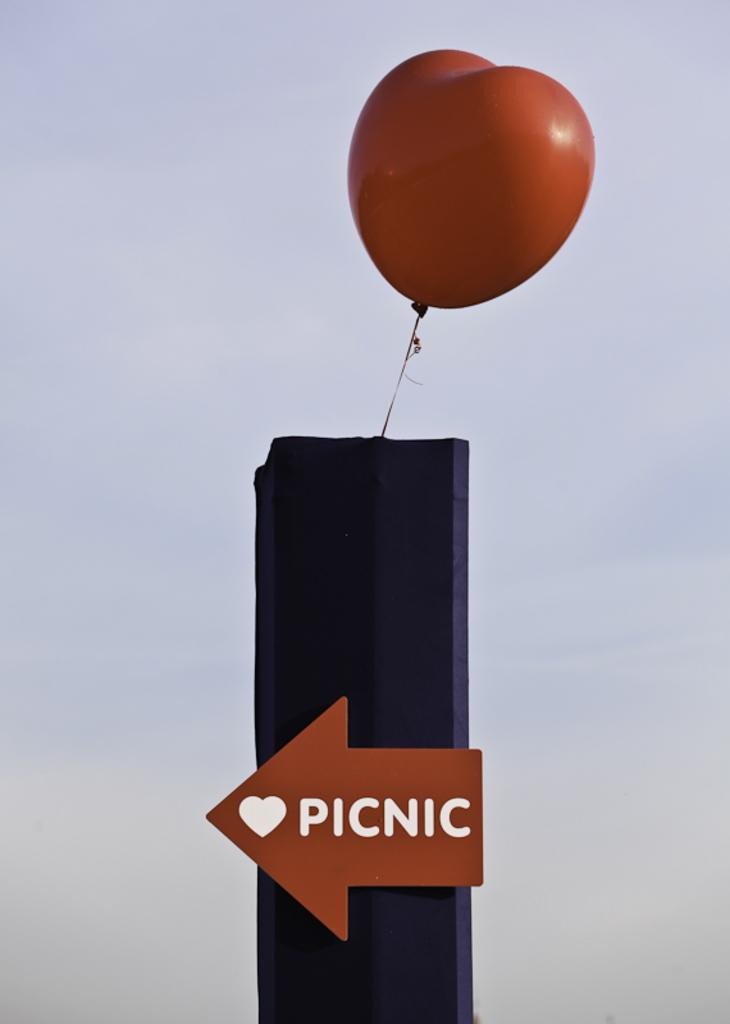What is the main object in the image? There is a balloon in the image. Where is the balloon located in the image? The balloon is at the top of the image. What can be seen in the background of the image? There is sky visible in the image. What word is written at the bottom of the image? The word "picnic" is written at the bottom of the image. How many beds are visible in the image? There are no beds present in the image. What type of basket is used for the picnic in the image? There is no basket present in the image; the word "picnic" is written at the bottom, but no actual picnic scene is depicted. 